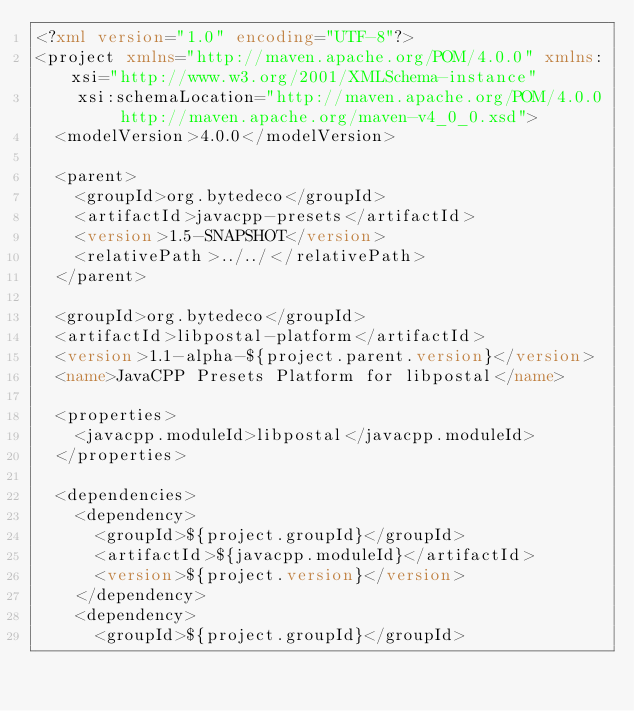Convert code to text. <code><loc_0><loc_0><loc_500><loc_500><_XML_><?xml version="1.0" encoding="UTF-8"?>
<project xmlns="http://maven.apache.org/POM/4.0.0" xmlns:xsi="http://www.w3.org/2001/XMLSchema-instance"
    xsi:schemaLocation="http://maven.apache.org/POM/4.0.0 http://maven.apache.org/maven-v4_0_0.xsd">
  <modelVersion>4.0.0</modelVersion>

  <parent>
    <groupId>org.bytedeco</groupId>
    <artifactId>javacpp-presets</artifactId>
    <version>1.5-SNAPSHOT</version>
    <relativePath>../../</relativePath>
  </parent>

  <groupId>org.bytedeco</groupId>
  <artifactId>libpostal-platform</artifactId>
  <version>1.1-alpha-${project.parent.version}</version>
  <name>JavaCPP Presets Platform for libpostal</name>

  <properties>
    <javacpp.moduleId>libpostal</javacpp.moduleId>
  </properties>

  <dependencies>
    <dependency>
      <groupId>${project.groupId}</groupId>
      <artifactId>${javacpp.moduleId}</artifactId>
      <version>${project.version}</version>
    </dependency>
    <dependency>
      <groupId>${project.groupId}</groupId></code> 